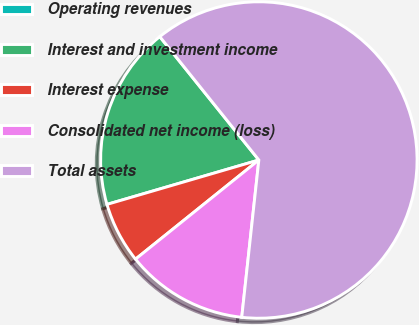Convert chart. <chart><loc_0><loc_0><loc_500><loc_500><pie_chart><fcel>Operating revenues<fcel>Interest and investment income<fcel>Interest expense<fcel>Consolidated net income (loss)<fcel>Total assets<nl><fcel>0.01%<fcel>18.75%<fcel>6.25%<fcel>12.5%<fcel>62.49%<nl></chart> 